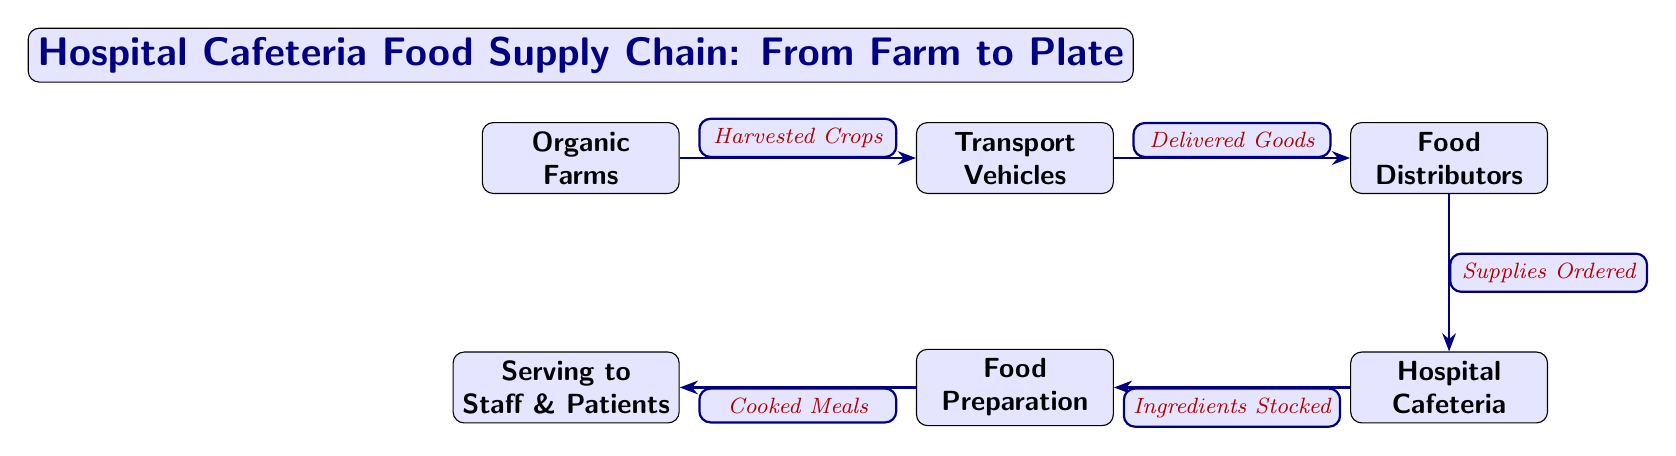What is the first node in the food supply chain? The first node in the food supply chain is labeled as "Organic Farms," which is where the process begins with the harvesting of crops.
Answer: Organic Farms How many nodes are present in the diagram? The diagram consists of six nodes: Organic Farms, Transport Vehicles, Food Distributors, Hospital Cafeteria, Food Preparation, and Serving to Staff & Patients.
Answer: Six What is the relationship between Transport Vehicles and Food Distributors? The relationship is described by the phrase "Delivered Goods," indicating that the transport vehicles deliver goods to the food distributors following transportation.
Answer: Delivered Goods Which node comes after Food Preparation? After Food Preparation, the next node is "Serving to Staff & Patients," where the meals are served after preparation.
Answer: Serving to Staff & Patients How do ingredients reach the Food Preparation node? Ingredients reach the Food Preparation node via the connection labeled "Ingredients Stocked," which indicates that they are stocked in the café prior to being prepared.
Answer: Ingredients Stocked What are the supplies ordered by the Food Distributors? The supplies ordered relate to the food items and products needed to stock the Hospital Cafeteria, as indicated by the label "Supplies Ordered" connecting the two nodes.
Answer: Supplies Ordered What does the "Harvested Crops" represent in the diagram? "Harvested Crops" represents the items that are taken from the Organic Farms and are ready for shipment via the Transport Vehicles, initiating the food supply chain.
Answer: Harvested Crops What is transported to the Hospital Cafeteria? The items transported to the Hospital Cafeteria are described as "Delivered Goods," which are the supplies received from the Food Distributors.
Answer: Delivered Goods What is the final stage in the food supply chain? The final stage in the food supply chain is "Serving to Staff & Patients," where the cooked meals are served after the food preparation has been completed.
Answer: Serving to Staff & Patients 